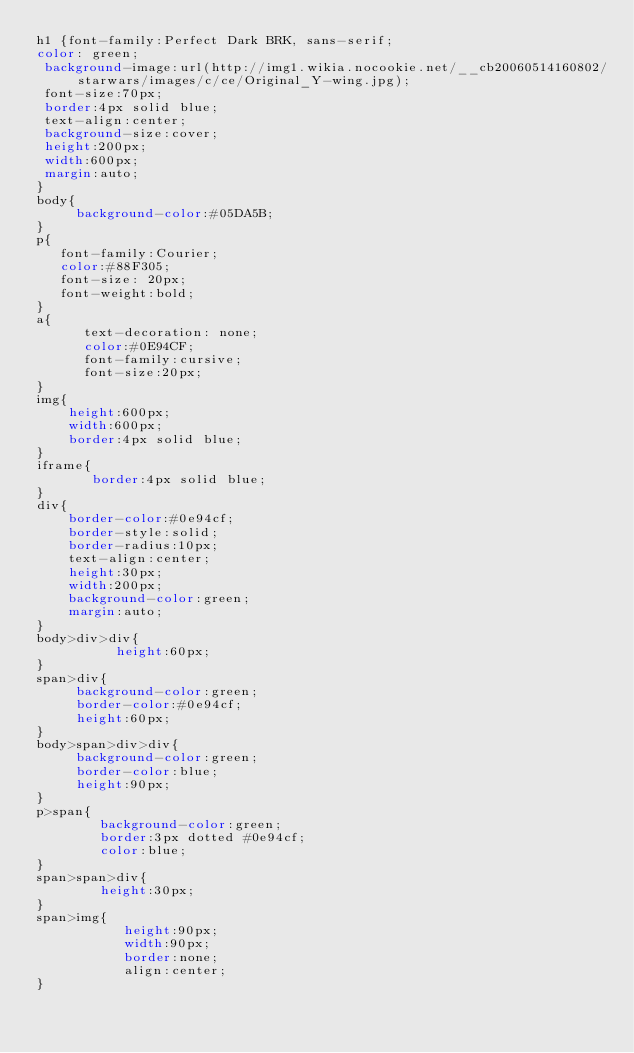<code> <loc_0><loc_0><loc_500><loc_500><_CSS_>h1 {font-family:Perfect Dark BRK, sans-serif;
color: green;
 background-image:url(http://img1.wikia.nocookie.net/__cb20060514160802/starwars/images/c/ce/Original_Y-wing.jpg);
 font-size:70px;
 border:4px solid blue;
 text-align:center;
 background-size:cover;
 height:200px;
 width:600px;
 margin:auto;
}                       
body{
     background-color:#05DA5B;
}
p{
   font-family:Courier;
   color:#88F305;
   font-size: 20px;
   font-weight:bold;
}
a{
      text-decoration: none;
      color:#0E94CF;
      font-family:cursive;
      font-size:20px;
}
img{
    height:600px;
    width:600px;
    border:4px solid blue;
}
iframe{
       border:4px solid blue;
}
div{
    border-color:#0e94cf;
    border-style:solid;
    border-radius:10px;
    text-align:center;
    height:30px;
    width:200px;
    background-color:green;
    margin:auto;
}
body>div>div{
          height:60px;
}
span>div{
     background-color:green;
     border-color:#0e94cf;
     height:60px;
}
body>span>div>div{
     background-color:green;
     border-color:blue;
     height:90px;
}
p>span{
        background-color:green;
        border:3px dotted #0e94cf;
        color:blue;
}
span>span>div{
        height:30px;
}
span>img{
           height:90px;
           width:90px;
           border:none;
           align:center;
}
</code> 